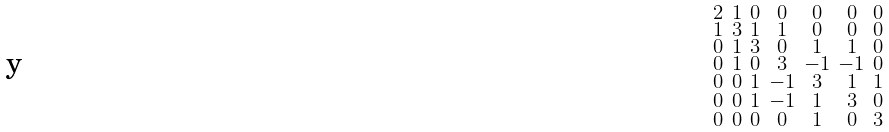Convert formula to latex. <formula><loc_0><loc_0><loc_500><loc_500>\begin{smallmatrix} 2 & 1 & 0 & 0 & 0 & 0 & 0 \\ 1 & 3 & 1 & 1 & 0 & 0 & 0 \\ 0 & 1 & 3 & 0 & 1 & 1 & 0 \\ 0 & 1 & 0 & 3 & - 1 & - 1 & 0 \\ 0 & 0 & 1 & - 1 & 3 & 1 & 1 \\ 0 & 0 & 1 & - 1 & 1 & 3 & 0 \\ 0 & 0 & 0 & 0 & 1 & 0 & 3 \end{smallmatrix}</formula> 